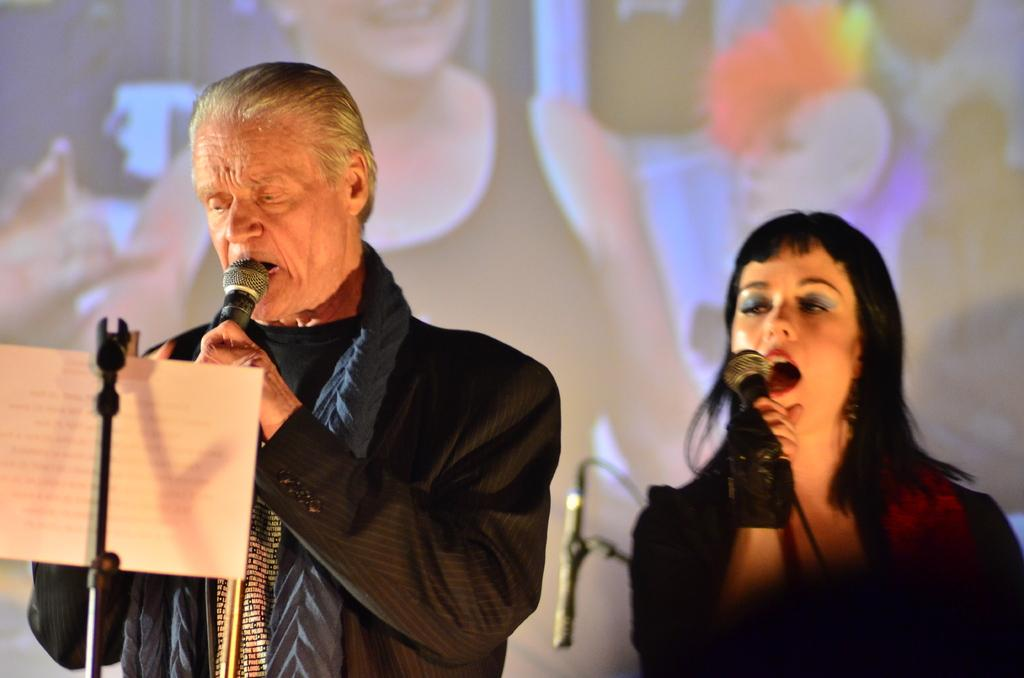What is in the background of the image? There is a screen in the background of the image. Who is present in the image? There is a woman and a man in the image. What are the man and woman holding in their hands? The man and woman are holding microphones in their hands. What are the man and woman doing in the image? The man and woman are singing. What else can be seen in the image? There is a paper visible in the image. Is the man wearing a crown in the image? There is no mention of a crown in the image, so we cannot determine if the man is wearing one. What is the man offering to the woman in the image? There is no indication of an offer being made in the image; the man and woman are simply singing. 